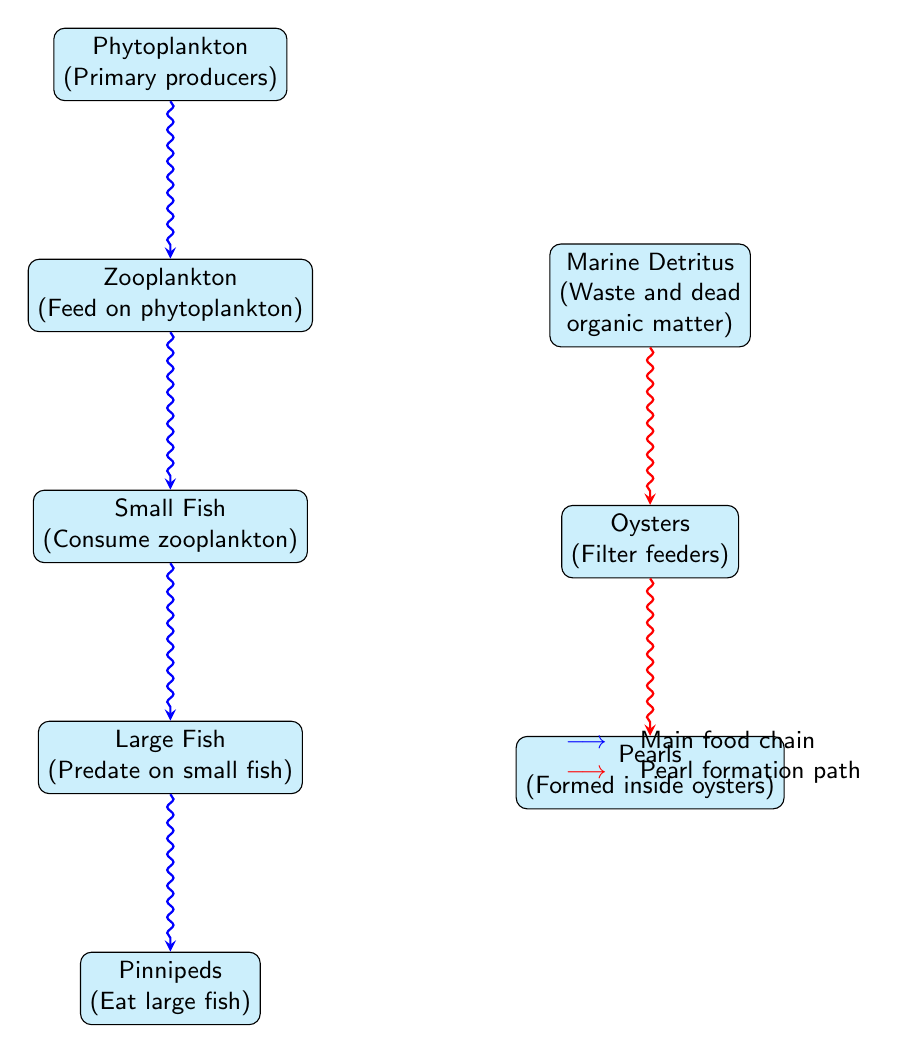What are the primary producers in this ecosystem? The diagram labels phytoplankton as the primary producers, indicating they are the first level in the food chain that converts sunlight to energy.
Answer: Phytoplankton How many levels are there in the main food chain? The main food chain consists of five nodes: phytoplankton, zooplankton, small fish, large fish, and pinnipeds, which indicates five distinct levels.
Answer: 5 Who feeds on zooplankton? The diagram shows that small fish are the organisms that consume zooplankton, thus indicating a direct feeding relationship.
Answer: Small Fish What leads to pearl formation? The diagram indicates that pearls are formed inside oysters, which are in turn fed by marine detritus, showing the pathway to pearl formation.
Answer: Oysters Which organism is at the top of the main food chain? The topmost organism in the main food chain is the pinnipeds, which predates on large fish, signifying their position at the apex of the food web.
Answer: Pinnipeds What type of feeders are oysters categorized as? Oysters are specifically labeled as filter feeders in the diagram, highlighting their role in the ecosystem as organisms that extract nutrients from water.
Answer: Filter feeders What is the relationship between marine detritus and oysters? The diagram illustrates a direct flow from marine detritus to oysters, indicating that oysters feed on waste and dead organic matter, which is crucial for their survival.
Answer: Feed How do large fish obtain energy? Large fish consume small fish, which in turn feed on zooplankton, leading to the conclusion that large fish obtain energy through this predation.
Answer: By consuming small fish What color is used to denote the main food chain in the diagram? The diagram uses blue arrows to highlight the connections within the main food chain, distinguishing it from the pathway related to pearl formation.
Answer: Blue What is the role of detritus in oyster feeding? Marine detritus serves as the source of nutrition for oysters, as shown in the flow leading to them, demonstrating the essential role of waste and dead matter in the ecosystem.
Answer: Nutrition source 